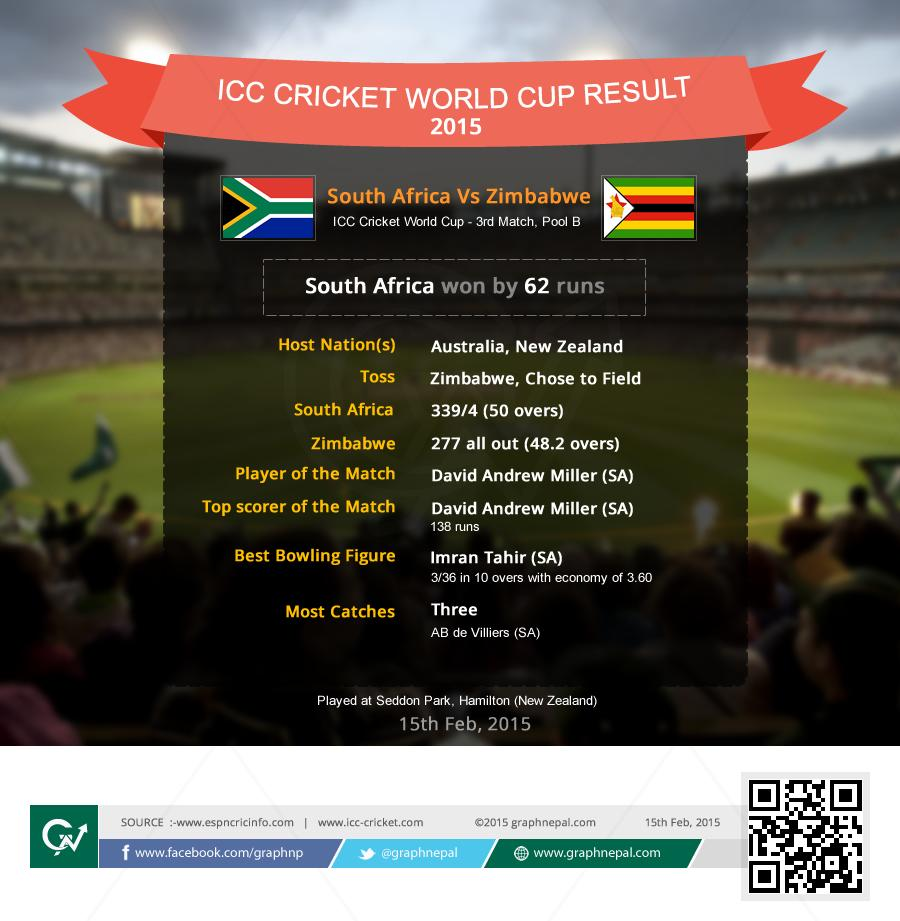Indicate a few pertinent items in this graphic. South Africa's score is 339/4. Four wickets of South Africa were taken. Imran Tahir took 3 wickets in the match. Imran Tahir gave 36 runs. In total, Zimbabwe lost 10 wickets during the match. 